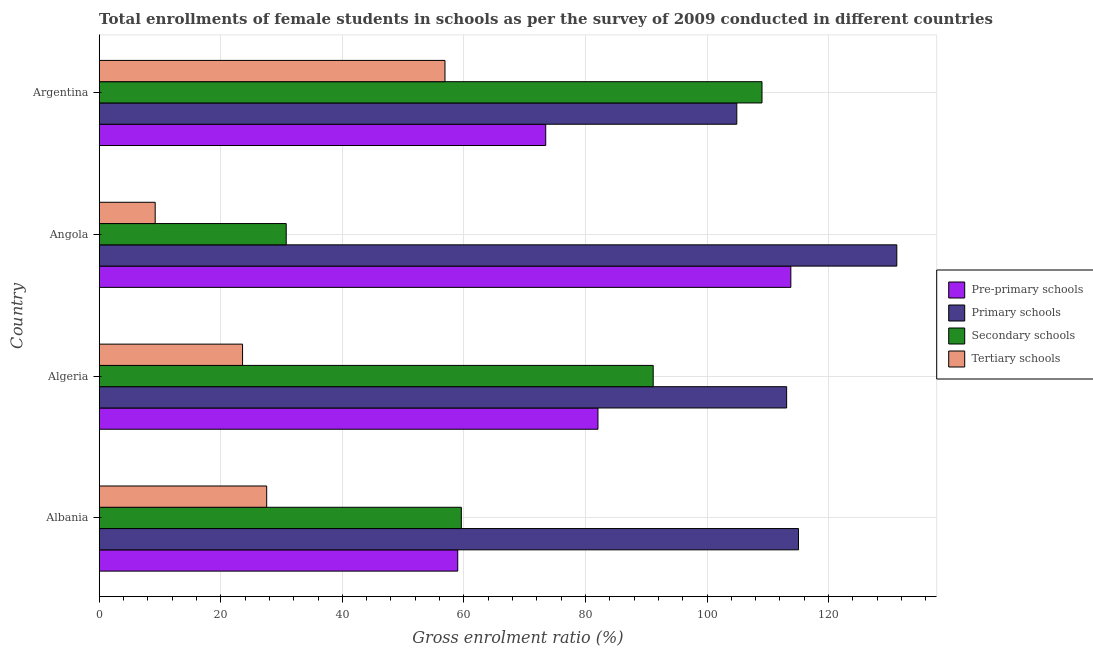Are the number of bars per tick equal to the number of legend labels?
Offer a terse response. Yes. What is the label of the 2nd group of bars from the top?
Offer a very short reply. Angola. In how many cases, is the number of bars for a given country not equal to the number of legend labels?
Provide a short and direct response. 0. What is the gross enrolment ratio(female) in primary schools in Algeria?
Make the answer very short. 113.1. Across all countries, what is the maximum gross enrolment ratio(female) in pre-primary schools?
Provide a short and direct response. 113.79. Across all countries, what is the minimum gross enrolment ratio(female) in secondary schools?
Your answer should be compact. 30.77. In which country was the gross enrolment ratio(female) in pre-primary schools minimum?
Keep it short and to the point. Albania. What is the total gross enrolment ratio(female) in secondary schools in the graph?
Ensure brevity in your answer.  290.53. What is the difference between the gross enrolment ratio(female) in pre-primary schools in Angola and that in Argentina?
Your answer should be very brief. 40.33. What is the difference between the gross enrolment ratio(female) in tertiary schools in Angola and the gross enrolment ratio(female) in secondary schools in Algeria?
Provide a short and direct response. -81.93. What is the average gross enrolment ratio(female) in secondary schools per country?
Make the answer very short. 72.63. What is the difference between the gross enrolment ratio(female) in secondary schools and gross enrolment ratio(female) in tertiary schools in Argentina?
Your answer should be very brief. 52.16. In how many countries, is the gross enrolment ratio(female) in tertiary schools greater than 60 %?
Provide a succinct answer. 0. What is the ratio of the gross enrolment ratio(female) in primary schools in Angola to that in Argentina?
Keep it short and to the point. 1.25. Is the gross enrolment ratio(female) in pre-primary schools in Algeria less than that in Angola?
Provide a succinct answer. Yes. What is the difference between the highest and the second highest gross enrolment ratio(female) in primary schools?
Make the answer very short. 16.18. What is the difference between the highest and the lowest gross enrolment ratio(female) in tertiary schools?
Make the answer very short. 47.68. Is the sum of the gross enrolment ratio(female) in tertiary schools in Albania and Argentina greater than the maximum gross enrolment ratio(female) in pre-primary schools across all countries?
Keep it short and to the point. No. What does the 4th bar from the top in Argentina represents?
Give a very brief answer. Pre-primary schools. What does the 1st bar from the bottom in Angola represents?
Give a very brief answer. Pre-primary schools. How many bars are there?
Provide a short and direct response. 16. Does the graph contain grids?
Your answer should be very brief. Yes. Where does the legend appear in the graph?
Your answer should be very brief. Center right. What is the title of the graph?
Your answer should be compact. Total enrollments of female students in schools as per the survey of 2009 conducted in different countries. What is the label or title of the X-axis?
Your answer should be compact. Gross enrolment ratio (%). What is the label or title of the Y-axis?
Offer a terse response. Country. What is the Gross enrolment ratio (%) in Pre-primary schools in Albania?
Provide a short and direct response. 58.99. What is the Gross enrolment ratio (%) of Primary schools in Albania?
Your answer should be very brief. 115.04. What is the Gross enrolment ratio (%) of Secondary schools in Albania?
Your answer should be very brief. 59.58. What is the Gross enrolment ratio (%) of Tertiary schools in Albania?
Offer a very short reply. 27.55. What is the Gross enrolment ratio (%) of Pre-primary schools in Algeria?
Offer a terse response. 82.05. What is the Gross enrolment ratio (%) of Primary schools in Algeria?
Give a very brief answer. 113.1. What is the Gross enrolment ratio (%) in Secondary schools in Algeria?
Your answer should be very brief. 91.14. What is the Gross enrolment ratio (%) in Tertiary schools in Algeria?
Your answer should be very brief. 23.58. What is the Gross enrolment ratio (%) in Pre-primary schools in Angola?
Your response must be concise. 113.79. What is the Gross enrolment ratio (%) of Primary schools in Angola?
Ensure brevity in your answer.  131.22. What is the Gross enrolment ratio (%) of Secondary schools in Angola?
Make the answer very short. 30.77. What is the Gross enrolment ratio (%) in Tertiary schools in Angola?
Your response must be concise. 9.21. What is the Gross enrolment ratio (%) of Pre-primary schools in Argentina?
Provide a succinct answer. 73.46. What is the Gross enrolment ratio (%) in Primary schools in Argentina?
Offer a very short reply. 104.9. What is the Gross enrolment ratio (%) in Secondary schools in Argentina?
Offer a very short reply. 109.04. What is the Gross enrolment ratio (%) of Tertiary schools in Argentina?
Your response must be concise. 56.89. Across all countries, what is the maximum Gross enrolment ratio (%) of Pre-primary schools?
Provide a short and direct response. 113.79. Across all countries, what is the maximum Gross enrolment ratio (%) in Primary schools?
Your answer should be very brief. 131.22. Across all countries, what is the maximum Gross enrolment ratio (%) in Secondary schools?
Make the answer very short. 109.04. Across all countries, what is the maximum Gross enrolment ratio (%) in Tertiary schools?
Your answer should be very brief. 56.89. Across all countries, what is the minimum Gross enrolment ratio (%) of Pre-primary schools?
Provide a short and direct response. 58.99. Across all countries, what is the minimum Gross enrolment ratio (%) in Primary schools?
Provide a succinct answer. 104.9. Across all countries, what is the minimum Gross enrolment ratio (%) in Secondary schools?
Your response must be concise. 30.77. Across all countries, what is the minimum Gross enrolment ratio (%) of Tertiary schools?
Your answer should be compact. 9.21. What is the total Gross enrolment ratio (%) of Pre-primary schools in the graph?
Your answer should be compact. 328.29. What is the total Gross enrolment ratio (%) of Primary schools in the graph?
Give a very brief answer. 464.26. What is the total Gross enrolment ratio (%) of Secondary schools in the graph?
Keep it short and to the point. 290.53. What is the total Gross enrolment ratio (%) of Tertiary schools in the graph?
Make the answer very short. 117.23. What is the difference between the Gross enrolment ratio (%) of Pre-primary schools in Albania and that in Algeria?
Offer a terse response. -23.07. What is the difference between the Gross enrolment ratio (%) in Primary schools in Albania and that in Algeria?
Ensure brevity in your answer.  1.95. What is the difference between the Gross enrolment ratio (%) of Secondary schools in Albania and that in Algeria?
Give a very brief answer. -31.56. What is the difference between the Gross enrolment ratio (%) of Tertiary schools in Albania and that in Algeria?
Offer a terse response. 3.97. What is the difference between the Gross enrolment ratio (%) of Pre-primary schools in Albania and that in Angola?
Your answer should be very brief. -54.8. What is the difference between the Gross enrolment ratio (%) of Primary schools in Albania and that in Angola?
Your answer should be very brief. -16.18. What is the difference between the Gross enrolment ratio (%) of Secondary schools in Albania and that in Angola?
Offer a terse response. 28.81. What is the difference between the Gross enrolment ratio (%) in Tertiary schools in Albania and that in Angola?
Provide a short and direct response. 18.34. What is the difference between the Gross enrolment ratio (%) of Pre-primary schools in Albania and that in Argentina?
Make the answer very short. -14.48. What is the difference between the Gross enrolment ratio (%) in Primary schools in Albania and that in Argentina?
Keep it short and to the point. 10.15. What is the difference between the Gross enrolment ratio (%) of Secondary schools in Albania and that in Argentina?
Ensure brevity in your answer.  -49.46. What is the difference between the Gross enrolment ratio (%) in Tertiary schools in Albania and that in Argentina?
Your answer should be compact. -29.33. What is the difference between the Gross enrolment ratio (%) in Pre-primary schools in Algeria and that in Angola?
Your answer should be compact. -31.73. What is the difference between the Gross enrolment ratio (%) in Primary schools in Algeria and that in Angola?
Keep it short and to the point. -18.13. What is the difference between the Gross enrolment ratio (%) of Secondary schools in Algeria and that in Angola?
Your answer should be compact. 60.38. What is the difference between the Gross enrolment ratio (%) of Tertiary schools in Algeria and that in Angola?
Provide a short and direct response. 14.37. What is the difference between the Gross enrolment ratio (%) in Pre-primary schools in Algeria and that in Argentina?
Offer a terse response. 8.59. What is the difference between the Gross enrolment ratio (%) in Primary schools in Algeria and that in Argentina?
Your answer should be very brief. 8.2. What is the difference between the Gross enrolment ratio (%) of Secondary schools in Algeria and that in Argentina?
Make the answer very short. -17.9. What is the difference between the Gross enrolment ratio (%) of Tertiary schools in Algeria and that in Argentina?
Provide a short and direct response. -33.3. What is the difference between the Gross enrolment ratio (%) in Pre-primary schools in Angola and that in Argentina?
Your answer should be compact. 40.33. What is the difference between the Gross enrolment ratio (%) in Primary schools in Angola and that in Argentina?
Offer a terse response. 26.33. What is the difference between the Gross enrolment ratio (%) of Secondary schools in Angola and that in Argentina?
Provide a succinct answer. -78.28. What is the difference between the Gross enrolment ratio (%) of Tertiary schools in Angola and that in Argentina?
Offer a very short reply. -47.68. What is the difference between the Gross enrolment ratio (%) in Pre-primary schools in Albania and the Gross enrolment ratio (%) in Primary schools in Algeria?
Provide a succinct answer. -54.11. What is the difference between the Gross enrolment ratio (%) in Pre-primary schools in Albania and the Gross enrolment ratio (%) in Secondary schools in Algeria?
Keep it short and to the point. -32.16. What is the difference between the Gross enrolment ratio (%) of Pre-primary schools in Albania and the Gross enrolment ratio (%) of Tertiary schools in Algeria?
Your answer should be compact. 35.4. What is the difference between the Gross enrolment ratio (%) in Primary schools in Albania and the Gross enrolment ratio (%) in Secondary schools in Algeria?
Your answer should be very brief. 23.9. What is the difference between the Gross enrolment ratio (%) in Primary schools in Albania and the Gross enrolment ratio (%) in Tertiary schools in Algeria?
Make the answer very short. 91.46. What is the difference between the Gross enrolment ratio (%) of Secondary schools in Albania and the Gross enrolment ratio (%) of Tertiary schools in Algeria?
Offer a very short reply. 36. What is the difference between the Gross enrolment ratio (%) in Pre-primary schools in Albania and the Gross enrolment ratio (%) in Primary schools in Angola?
Keep it short and to the point. -72.24. What is the difference between the Gross enrolment ratio (%) in Pre-primary schools in Albania and the Gross enrolment ratio (%) in Secondary schools in Angola?
Your answer should be compact. 28.22. What is the difference between the Gross enrolment ratio (%) in Pre-primary schools in Albania and the Gross enrolment ratio (%) in Tertiary schools in Angola?
Provide a short and direct response. 49.78. What is the difference between the Gross enrolment ratio (%) in Primary schools in Albania and the Gross enrolment ratio (%) in Secondary schools in Angola?
Your answer should be very brief. 84.28. What is the difference between the Gross enrolment ratio (%) of Primary schools in Albania and the Gross enrolment ratio (%) of Tertiary schools in Angola?
Offer a very short reply. 105.84. What is the difference between the Gross enrolment ratio (%) in Secondary schools in Albania and the Gross enrolment ratio (%) in Tertiary schools in Angola?
Keep it short and to the point. 50.37. What is the difference between the Gross enrolment ratio (%) of Pre-primary schools in Albania and the Gross enrolment ratio (%) of Primary schools in Argentina?
Give a very brief answer. -45.91. What is the difference between the Gross enrolment ratio (%) of Pre-primary schools in Albania and the Gross enrolment ratio (%) of Secondary schools in Argentina?
Make the answer very short. -50.06. What is the difference between the Gross enrolment ratio (%) of Pre-primary schools in Albania and the Gross enrolment ratio (%) of Tertiary schools in Argentina?
Provide a succinct answer. 2.1. What is the difference between the Gross enrolment ratio (%) in Primary schools in Albania and the Gross enrolment ratio (%) in Secondary schools in Argentina?
Your response must be concise. 6. What is the difference between the Gross enrolment ratio (%) of Primary schools in Albania and the Gross enrolment ratio (%) of Tertiary schools in Argentina?
Offer a very short reply. 58.16. What is the difference between the Gross enrolment ratio (%) of Secondary schools in Albania and the Gross enrolment ratio (%) of Tertiary schools in Argentina?
Offer a very short reply. 2.69. What is the difference between the Gross enrolment ratio (%) of Pre-primary schools in Algeria and the Gross enrolment ratio (%) of Primary schools in Angola?
Provide a succinct answer. -49.17. What is the difference between the Gross enrolment ratio (%) in Pre-primary schools in Algeria and the Gross enrolment ratio (%) in Secondary schools in Angola?
Your response must be concise. 51.29. What is the difference between the Gross enrolment ratio (%) in Pre-primary schools in Algeria and the Gross enrolment ratio (%) in Tertiary schools in Angola?
Your answer should be compact. 72.84. What is the difference between the Gross enrolment ratio (%) of Primary schools in Algeria and the Gross enrolment ratio (%) of Secondary schools in Angola?
Ensure brevity in your answer.  82.33. What is the difference between the Gross enrolment ratio (%) in Primary schools in Algeria and the Gross enrolment ratio (%) in Tertiary schools in Angola?
Make the answer very short. 103.89. What is the difference between the Gross enrolment ratio (%) in Secondary schools in Algeria and the Gross enrolment ratio (%) in Tertiary schools in Angola?
Make the answer very short. 81.93. What is the difference between the Gross enrolment ratio (%) of Pre-primary schools in Algeria and the Gross enrolment ratio (%) of Primary schools in Argentina?
Your response must be concise. -22.84. What is the difference between the Gross enrolment ratio (%) of Pre-primary schools in Algeria and the Gross enrolment ratio (%) of Secondary schools in Argentina?
Your answer should be compact. -26.99. What is the difference between the Gross enrolment ratio (%) of Pre-primary schools in Algeria and the Gross enrolment ratio (%) of Tertiary schools in Argentina?
Offer a very short reply. 25.17. What is the difference between the Gross enrolment ratio (%) in Primary schools in Algeria and the Gross enrolment ratio (%) in Secondary schools in Argentina?
Keep it short and to the point. 4.05. What is the difference between the Gross enrolment ratio (%) of Primary schools in Algeria and the Gross enrolment ratio (%) of Tertiary schools in Argentina?
Keep it short and to the point. 56.21. What is the difference between the Gross enrolment ratio (%) in Secondary schools in Algeria and the Gross enrolment ratio (%) in Tertiary schools in Argentina?
Ensure brevity in your answer.  34.26. What is the difference between the Gross enrolment ratio (%) of Pre-primary schools in Angola and the Gross enrolment ratio (%) of Primary schools in Argentina?
Ensure brevity in your answer.  8.89. What is the difference between the Gross enrolment ratio (%) of Pre-primary schools in Angola and the Gross enrolment ratio (%) of Secondary schools in Argentina?
Your answer should be very brief. 4.74. What is the difference between the Gross enrolment ratio (%) of Pre-primary schools in Angola and the Gross enrolment ratio (%) of Tertiary schools in Argentina?
Provide a succinct answer. 56.9. What is the difference between the Gross enrolment ratio (%) in Primary schools in Angola and the Gross enrolment ratio (%) in Secondary schools in Argentina?
Offer a terse response. 22.18. What is the difference between the Gross enrolment ratio (%) of Primary schools in Angola and the Gross enrolment ratio (%) of Tertiary schools in Argentina?
Give a very brief answer. 74.34. What is the difference between the Gross enrolment ratio (%) in Secondary schools in Angola and the Gross enrolment ratio (%) in Tertiary schools in Argentina?
Make the answer very short. -26.12. What is the average Gross enrolment ratio (%) in Pre-primary schools per country?
Your answer should be compact. 82.07. What is the average Gross enrolment ratio (%) of Primary schools per country?
Provide a succinct answer. 116.07. What is the average Gross enrolment ratio (%) in Secondary schools per country?
Your answer should be compact. 72.63. What is the average Gross enrolment ratio (%) of Tertiary schools per country?
Offer a very short reply. 29.31. What is the difference between the Gross enrolment ratio (%) of Pre-primary schools and Gross enrolment ratio (%) of Primary schools in Albania?
Your answer should be compact. -56.06. What is the difference between the Gross enrolment ratio (%) in Pre-primary schools and Gross enrolment ratio (%) in Secondary schools in Albania?
Keep it short and to the point. -0.59. What is the difference between the Gross enrolment ratio (%) of Pre-primary schools and Gross enrolment ratio (%) of Tertiary schools in Albania?
Provide a short and direct response. 31.43. What is the difference between the Gross enrolment ratio (%) of Primary schools and Gross enrolment ratio (%) of Secondary schools in Albania?
Your answer should be very brief. 55.47. What is the difference between the Gross enrolment ratio (%) of Primary schools and Gross enrolment ratio (%) of Tertiary schools in Albania?
Ensure brevity in your answer.  87.49. What is the difference between the Gross enrolment ratio (%) in Secondary schools and Gross enrolment ratio (%) in Tertiary schools in Albania?
Provide a short and direct response. 32.03. What is the difference between the Gross enrolment ratio (%) in Pre-primary schools and Gross enrolment ratio (%) in Primary schools in Algeria?
Make the answer very short. -31.04. What is the difference between the Gross enrolment ratio (%) of Pre-primary schools and Gross enrolment ratio (%) of Secondary schools in Algeria?
Your answer should be compact. -9.09. What is the difference between the Gross enrolment ratio (%) of Pre-primary schools and Gross enrolment ratio (%) of Tertiary schools in Algeria?
Offer a very short reply. 58.47. What is the difference between the Gross enrolment ratio (%) of Primary schools and Gross enrolment ratio (%) of Secondary schools in Algeria?
Keep it short and to the point. 21.95. What is the difference between the Gross enrolment ratio (%) in Primary schools and Gross enrolment ratio (%) in Tertiary schools in Algeria?
Provide a succinct answer. 89.51. What is the difference between the Gross enrolment ratio (%) in Secondary schools and Gross enrolment ratio (%) in Tertiary schools in Algeria?
Provide a short and direct response. 67.56. What is the difference between the Gross enrolment ratio (%) of Pre-primary schools and Gross enrolment ratio (%) of Primary schools in Angola?
Provide a short and direct response. -17.44. What is the difference between the Gross enrolment ratio (%) in Pre-primary schools and Gross enrolment ratio (%) in Secondary schools in Angola?
Your answer should be compact. 83.02. What is the difference between the Gross enrolment ratio (%) in Pre-primary schools and Gross enrolment ratio (%) in Tertiary schools in Angola?
Offer a very short reply. 104.58. What is the difference between the Gross enrolment ratio (%) of Primary schools and Gross enrolment ratio (%) of Secondary schools in Angola?
Give a very brief answer. 100.46. What is the difference between the Gross enrolment ratio (%) of Primary schools and Gross enrolment ratio (%) of Tertiary schools in Angola?
Keep it short and to the point. 122.01. What is the difference between the Gross enrolment ratio (%) of Secondary schools and Gross enrolment ratio (%) of Tertiary schools in Angola?
Your answer should be compact. 21.56. What is the difference between the Gross enrolment ratio (%) in Pre-primary schools and Gross enrolment ratio (%) in Primary schools in Argentina?
Give a very brief answer. -31.44. What is the difference between the Gross enrolment ratio (%) of Pre-primary schools and Gross enrolment ratio (%) of Secondary schools in Argentina?
Keep it short and to the point. -35.58. What is the difference between the Gross enrolment ratio (%) in Pre-primary schools and Gross enrolment ratio (%) in Tertiary schools in Argentina?
Provide a short and direct response. 16.58. What is the difference between the Gross enrolment ratio (%) in Primary schools and Gross enrolment ratio (%) in Secondary schools in Argentina?
Provide a succinct answer. -4.15. What is the difference between the Gross enrolment ratio (%) of Primary schools and Gross enrolment ratio (%) of Tertiary schools in Argentina?
Make the answer very short. 48.01. What is the difference between the Gross enrolment ratio (%) in Secondary schools and Gross enrolment ratio (%) in Tertiary schools in Argentina?
Your answer should be compact. 52.16. What is the ratio of the Gross enrolment ratio (%) of Pre-primary schools in Albania to that in Algeria?
Make the answer very short. 0.72. What is the ratio of the Gross enrolment ratio (%) of Primary schools in Albania to that in Algeria?
Give a very brief answer. 1.02. What is the ratio of the Gross enrolment ratio (%) of Secondary schools in Albania to that in Algeria?
Your response must be concise. 0.65. What is the ratio of the Gross enrolment ratio (%) of Tertiary schools in Albania to that in Algeria?
Offer a terse response. 1.17. What is the ratio of the Gross enrolment ratio (%) in Pre-primary schools in Albania to that in Angola?
Give a very brief answer. 0.52. What is the ratio of the Gross enrolment ratio (%) in Primary schools in Albania to that in Angola?
Your answer should be very brief. 0.88. What is the ratio of the Gross enrolment ratio (%) of Secondary schools in Albania to that in Angola?
Your answer should be very brief. 1.94. What is the ratio of the Gross enrolment ratio (%) in Tertiary schools in Albania to that in Angola?
Provide a short and direct response. 2.99. What is the ratio of the Gross enrolment ratio (%) in Pre-primary schools in Albania to that in Argentina?
Offer a very short reply. 0.8. What is the ratio of the Gross enrolment ratio (%) in Primary schools in Albania to that in Argentina?
Offer a very short reply. 1.1. What is the ratio of the Gross enrolment ratio (%) in Secondary schools in Albania to that in Argentina?
Give a very brief answer. 0.55. What is the ratio of the Gross enrolment ratio (%) in Tertiary schools in Albania to that in Argentina?
Provide a succinct answer. 0.48. What is the ratio of the Gross enrolment ratio (%) of Pre-primary schools in Algeria to that in Angola?
Your answer should be very brief. 0.72. What is the ratio of the Gross enrolment ratio (%) in Primary schools in Algeria to that in Angola?
Provide a succinct answer. 0.86. What is the ratio of the Gross enrolment ratio (%) in Secondary schools in Algeria to that in Angola?
Your response must be concise. 2.96. What is the ratio of the Gross enrolment ratio (%) of Tertiary schools in Algeria to that in Angola?
Provide a short and direct response. 2.56. What is the ratio of the Gross enrolment ratio (%) in Pre-primary schools in Algeria to that in Argentina?
Give a very brief answer. 1.12. What is the ratio of the Gross enrolment ratio (%) of Primary schools in Algeria to that in Argentina?
Offer a very short reply. 1.08. What is the ratio of the Gross enrolment ratio (%) in Secondary schools in Algeria to that in Argentina?
Offer a terse response. 0.84. What is the ratio of the Gross enrolment ratio (%) of Tertiary schools in Algeria to that in Argentina?
Keep it short and to the point. 0.41. What is the ratio of the Gross enrolment ratio (%) in Pre-primary schools in Angola to that in Argentina?
Your response must be concise. 1.55. What is the ratio of the Gross enrolment ratio (%) in Primary schools in Angola to that in Argentina?
Keep it short and to the point. 1.25. What is the ratio of the Gross enrolment ratio (%) of Secondary schools in Angola to that in Argentina?
Give a very brief answer. 0.28. What is the ratio of the Gross enrolment ratio (%) of Tertiary schools in Angola to that in Argentina?
Your answer should be very brief. 0.16. What is the difference between the highest and the second highest Gross enrolment ratio (%) in Pre-primary schools?
Make the answer very short. 31.73. What is the difference between the highest and the second highest Gross enrolment ratio (%) in Primary schools?
Your answer should be very brief. 16.18. What is the difference between the highest and the second highest Gross enrolment ratio (%) in Secondary schools?
Offer a terse response. 17.9. What is the difference between the highest and the second highest Gross enrolment ratio (%) of Tertiary schools?
Offer a very short reply. 29.33. What is the difference between the highest and the lowest Gross enrolment ratio (%) of Pre-primary schools?
Keep it short and to the point. 54.8. What is the difference between the highest and the lowest Gross enrolment ratio (%) in Primary schools?
Offer a very short reply. 26.33. What is the difference between the highest and the lowest Gross enrolment ratio (%) of Secondary schools?
Give a very brief answer. 78.28. What is the difference between the highest and the lowest Gross enrolment ratio (%) in Tertiary schools?
Make the answer very short. 47.68. 